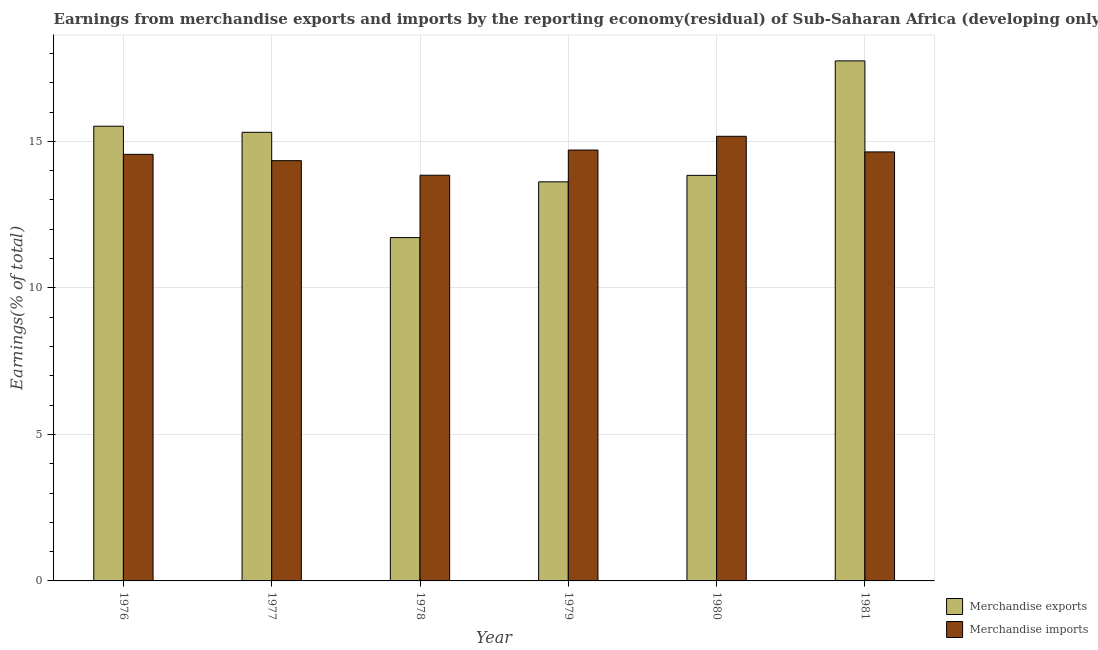How many groups of bars are there?
Provide a succinct answer. 6. In how many cases, is the number of bars for a given year not equal to the number of legend labels?
Make the answer very short. 0. What is the earnings from merchandise imports in 1977?
Ensure brevity in your answer.  14.34. Across all years, what is the maximum earnings from merchandise imports?
Your answer should be very brief. 15.17. Across all years, what is the minimum earnings from merchandise exports?
Offer a terse response. 11.72. In which year was the earnings from merchandise imports minimum?
Your answer should be compact. 1978. What is the total earnings from merchandise imports in the graph?
Your answer should be compact. 87.26. What is the difference between the earnings from merchandise exports in 1977 and that in 1979?
Your answer should be compact. 1.69. What is the difference between the earnings from merchandise exports in 1976 and the earnings from merchandise imports in 1981?
Your answer should be very brief. -2.23. What is the average earnings from merchandise imports per year?
Provide a succinct answer. 14.54. In the year 1977, what is the difference between the earnings from merchandise exports and earnings from merchandise imports?
Give a very brief answer. 0. In how many years, is the earnings from merchandise exports greater than 11 %?
Your answer should be compact. 6. What is the ratio of the earnings from merchandise imports in 1977 to that in 1980?
Give a very brief answer. 0.95. Is the earnings from merchandise imports in 1976 less than that in 1979?
Provide a succinct answer. Yes. Is the difference between the earnings from merchandise imports in 1976 and 1981 greater than the difference between the earnings from merchandise exports in 1976 and 1981?
Provide a short and direct response. No. What is the difference between the highest and the second highest earnings from merchandise imports?
Offer a very short reply. 0.47. What is the difference between the highest and the lowest earnings from merchandise exports?
Make the answer very short. 6.03. Is the sum of the earnings from merchandise imports in 1978 and 1979 greater than the maximum earnings from merchandise exports across all years?
Keep it short and to the point. Yes. What does the 2nd bar from the left in 1979 represents?
Your response must be concise. Merchandise imports. What does the 1st bar from the right in 1977 represents?
Your answer should be very brief. Merchandise imports. Are all the bars in the graph horizontal?
Provide a succinct answer. No. How many years are there in the graph?
Keep it short and to the point. 6. What is the difference between two consecutive major ticks on the Y-axis?
Provide a succinct answer. 5. Does the graph contain grids?
Make the answer very short. Yes. Where does the legend appear in the graph?
Your answer should be very brief. Bottom right. How are the legend labels stacked?
Your answer should be very brief. Vertical. What is the title of the graph?
Your answer should be very brief. Earnings from merchandise exports and imports by the reporting economy(residual) of Sub-Saharan Africa (developing only). What is the label or title of the X-axis?
Provide a succinct answer. Year. What is the label or title of the Y-axis?
Give a very brief answer. Earnings(% of total). What is the Earnings(% of total) in Merchandise exports in 1976?
Provide a short and direct response. 15.52. What is the Earnings(% of total) of Merchandise imports in 1976?
Offer a terse response. 14.56. What is the Earnings(% of total) in Merchandise exports in 1977?
Provide a succinct answer. 15.31. What is the Earnings(% of total) of Merchandise imports in 1977?
Your answer should be very brief. 14.34. What is the Earnings(% of total) in Merchandise exports in 1978?
Your answer should be compact. 11.72. What is the Earnings(% of total) in Merchandise imports in 1978?
Your response must be concise. 13.84. What is the Earnings(% of total) of Merchandise exports in 1979?
Keep it short and to the point. 13.62. What is the Earnings(% of total) of Merchandise imports in 1979?
Ensure brevity in your answer.  14.7. What is the Earnings(% of total) in Merchandise exports in 1980?
Ensure brevity in your answer.  13.84. What is the Earnings(% of total) of Merchandise imports in 1980?
Your response must be concise. 15.17. What is the Earnings(% of total) of Merchandise exports in 1981?
Your answer should be compact. 17.75. What is the Earnings(% of total) in Merchandise imports in 1981?
Your answer should be compact. 14.64. Across all years, what is the maximum Earnings(% of total) of Merchandise exports?
Your response must be concise. 17.75. Across all years, what is the maximum Earnings(% of total) of Merchandise imports?
Provide a short and direct response. 15.17. Across all years, what is the minimum Earnings(% of total) in Merchandise exports?
Your answer should be compact. 11.72. Across all years, what is the minimum Earnings(% of total) of Merchandise imports?
Offer a very short reply. 13.84. What is the total Earnings(% of total) in Merchandise exports in the graph?
Your answer should be compact. 87.74. What is the total Earnings(% of total) in Merchandise imports in the graph?
Your answer should be compact. 87.26. What is the difference between the Earnings(% of total) of Merchandise exports in 1976 and that in 1977?
Offer a very short reply. 0.21. What is the difference between the Earnings(% of total) of Merchandise imports in 1976 and that in 1977?
Your answer should be very brief. 0.22. What is the difference between the Earnings(% of total) in Merchandise exports in 1976 and that in 1978?
Offer a terse response. 3.8. What is the difference between the Earnings(% of total) in Merchandise imports in 1976 and that in 1978?
Your answer should be very brief. 0.71. What is the difference between the Earnings(% of total) in Merchandise exports in 1976 and that in 1979?
Provide a succinct answer. 1.9. What is the difference between the Earnings(% of total) of Merchandise imports in 1976 and that in 1979?
Ensure brevity in your answer.  -0.15. What is the difference between the Earnings(% of total) in Merchandise exports in 1976 and that in 1980?
Provide a short and direct response. 1.68. What is the difference between the Earnings(% of total) of Merchandise imports in 1976 and that in 1980?
Provide a succinct answer. -0.62. What is the difference between the Earnings(% of total) of Merchandise exports in 1976 and that in 1981?
Provide a succinct answer. -2.23. What is the difference between the Earnings(% of total) of Merchandise imports in 1976 and that in 1981?
Provide a succinct answer. -0.08. What is the difference between the Earnings(% of total) in Merchandise exports in 1977 and that in 1978?
Your answer should be very brief. 3.59. What is the difference between the Earnings(% of total) in Merchandise imports in 1977 and that in 1978?
Offer a terse response. 0.5. What is the difference between the Earnings(% of total) in Merchandise exports in 1977 and that in 1979?
Offer a terse response. 1.69. What is the difference between the Earnings(% of total) in Merchandise imports in 1977 and that in 1979?
Give a very brief answer. -0.36. What is the difference between the Earnings(% of total) in Merchandise exports in 1977 and that in 1980?
Your answer should be very brief. 1.47. What is the difference between the Earnings(% of total) of Merchandise imports in 1977 and that in 1980?
Give a very brief answer. -0.83. What is the difference between the Earnings(% of total) of Merchandise exports in 1977 and that in 1981?
Offer a very short reply. -2.44. What is the difference between the Earnings(% of total) of Merchandise imports in 1977 and that in 1981?
Your answer should be compact. -0.3. What is the difference between the Earnings(% of total) in Merchandise exports in 1978 and that in 1979?
Ensure brevity in your answer.  -1.9. What is the difference between the Earnings(% of total) of Merchandise imports in 1978 and that in 1979?
Offer a terse response. -0.86. What is the difference between the Earnings(% of total) of Merchandise exports in 1978 and that in 1980?
Offer a very short reply. -2.12. What is the difference between the Earnings(% of total) of Merchandise imports in 1978 and that in 1980?
Offer a very short reply. -1.33. What is the difference between the Earnings(% of total) of Merchandise exports in 1978 and that in 1981?
Provide a short and direct response. -6.03. What is the difference between the Earnings(% of total) of Merchandise imports in 1978 and that in 1981?
Make the answer very short. -0.8. What is the difference between the Earnings(% of total) of Merchandise exports in 1979 and that in 1980?
Provide a succinct answer. -0.22. What is the difference between the Earnings(% of total) in Merchandise imports in 1979 and that in 1980?
Keep it short and to the point. -0.47. What is the difference between the Earnings(% of total) in Merchandise exports in 1979 and that in 1981?
Ensure brevity in your answer.  -4.13. What is the difference between the Earnings(% of total) of Merchandise imports in 1979 and that in 1981?
Your answer should be compact. 0.06. What is the difference between the Earnings(% of total) of Merchandise exports in 1980 and that in 1981?
Your answer should be very brief. -3.91. What is the difference between the Earnings(% of total) of Merchandise imports in 1980 and that in 1981?
Provide a short and direct response. 0.53. What is the difference between the Earnings(% of total) of Merchandise exports in 1976 and the Earnings(% of total) of Merchandise imports in 1977?
Your answer should be very brief. 1.18. What is the difference between the Earnings(% of total) of Merchandise exports in 1976 and the Earnings(% of total) of Merchandise imports in 1978?
Give a very brief answer. 1.67. What is the difference between the Earnings(% of total) in Merchandise exports in 1976 and the Earnings(% of total) in Merchandise imports in 1979?
Your answer should be compact. 0.81. What is the difference between the Earnings(% of total) in Merchandise exports in 1976 and the Earnings(% of total) in Merchandise imports in 1980?
Keep it short and to the point. 0.34. What is the difference between the Earnings(% of total) in Merchandise exports in 1976 and the Earnings(% of total) in Merchandise imports in 1981?
Ensure brevity in your answer.  0.88. What is the difference between the Earnings(% of total) in Merchandise exports in 1977 and the Earnings(% of total) in Merchandise imports in 1978?
Provide a short and direct response. 1.47. What is the difference between the Earnings(% of total) in Merchandise exports in 1977 and the Earnings(% of total) in Merchandise imports in 1979?
Ensure brevity in your answer.  0.61. What is the difference between the Earnings(% of total) in Merchandise exports in 1977 and the Earnings(% of total) in Merchandise imports in 1980?
Ensure brevity in your answer.  0.14. What is the difference between the Earnings(% of total) of Merchandise exports in 1977 and the Earnings(% of total) of Merchandise imports in 1981?
Offer a terse response. 0.67. What is the difference between the Earnings(% of total) in Merchandise exports in 1978 and the Earnings(% of total) in Merchandise imports in 1979?
Keep it short and to the point. -2.99. What is the difference between the Earnings(% of total) in Merchandise exports in 1978 and the Earnings(% of total) in Merchandise imports in 1980?
Provide a succinct answer. -3.46. What is the difference between the Earnings(% of total) of Merchandise exports in 1978 and the Earnings(% of total) of Merchandise imports in 1981?
Your response must be concise. -2.92. What is the difference between the Earnings(% of total) in Merchandise exports in 1979 and the Earnings(% of total) in Merchandise imports in 1980?
Offer a very short reply. -1.55. What is the difference between the Earnings(% of total) in Merchandise exports in 1979 and the Earnings(% of total) in Merchandise imports in 1981?
Ensure brevity in your answer.  -1.02. What is the difference between the Earnings(% of total) of Merchandise exports in 1980 and the Earnings(% of total) of Merchandise imports in 1981?
Ensure brevity in your answer.  -0.8. What is the average Earnings(% of total) in Merchandise exports per year?
Keep it short and to the point. 14.62. What is the average Earnings(% of total) in Merchandise imports per year?
Offer a very short reply. 14.54. In the year 1976, what is the difference between the Earnings(% of total) in Merchandise exports and Earnings(% of total) in Merchandise imports?
Give a very brief answer. 0.96. In the year 1977, what is the difference between the Earnings(% of total) of Merchandise exports and Earnings(% of total) of Merchandise imports?
Make the answer very short. 0.97. In the year 1978, what is the difference between the Earnings(% of total) of Merchandise exports and Earnings(% of total) of Merchandise imports?
Provide a short and direct response. -2.13. In the year 1979, what is the difference between the Earnings(% of total) in Merchandise exports and Earnings(% of total) in Merchandise imports?
Your response must be concise. -1.08. In the year 1980, what is the difference between the Earnings(% of total) of Merchandise exports and Earnings(% of total) of Merchandise imports?
Your answer should be compact. -1.33. In the year 1981, what is the difference between the Earnings(% of total) in Merchandise exports and Earnings(% of total) in Merchandise imports?
Offer a terse response. 3.11. What is the ratio of the Earnings(% of total) in Merchandise exports in 1976 to that in 1977?
Provide a short and direct response. 1.01. What is the ratio of the Earnings(% of total) in Merchandise imports in 1976 to that in 1977?
Offer a very short reply. 1.02. What is the ratio of the Earnings(% of total) in Merchandise exports in 1976 to that in 1978?
Provide a short and direct response. 1.32. What is the ratio of the Earnings(% of total) in Merchandise imports in 1976 to that in 1978?
Offer a terse response. 1.05. What is the ratio of the Earnings(% of total) of Merchandise exports in 1976 to that in 1979?
Offer a very short reply. 1.14. What is the ratio of the Earnings(% of total) of Merchandise exports in 1976 to that in 1980?
Provide a succinct answer. 1.12. What is the ratio of the Earnings(% of total) of Merchandise imports in 1976 to that in 1980?
Offer a very short reply. 0.96. What is the ratio of the Earnings(% of total) in Merchandise exports in 1976 to that in 1981?
Your answer should be compact. 0.87. What is the ratio of the Earnings(% of total) of Merchandise imports in 1976 to that in 1981?
Provide a short and direct response. 0.99. What is the ratio of the Earnings(% of total) in Merchandise exports in 1977 to that in 1978?
Make the answer very short. 1.31. What is the ratio of the Earnings(% of total) in Merchandise imports in 1977 to that in 1978?
Make the answer very short. 1.04. What is the ratio of the Earnings(% of total) of Merchandise exports in 1977 to that in 1979?
Offer a very short reply. 1.12. What is the ratio of the Earnings(% of total) of Merchandise imports in 1977 to that in 1979?
Your response must be concise. 0.98. What is the ratio of the Earnings(% of total) in Merchandise exports in 1977 to that in 1980?
Your answer should be compact. 1.11. What is the ratio of the Earnings(% of total) in Merchandise imports in 1977 to that in 1980?
Your answer should be compact. 0.95. What is the ratio of the Earnings(% of total) of Merchandise exports in 1977 to that in 1981?
Provide a short and direct response. 0.86. What is the ratio of the Earnings(% of total) in Merchandise imports in 1977 to that in 1981?
Provide a succinct answer. 0.98. What is the ratio of the Earnings(% of total) of Merchandise exports in 1978 to that in 1979?
Make the answer very short. 0.86. What is the ratio of the Earnings(% of total) of Merchandise imports in 1978 to that in 1979?
Make the answer very short. 0.94. What is the ratio of the Earnings(% of total) of Merchandise exports in 1978 to that in 1980?
Your answer should be very brief. 0.85. What is the ratio of the Earnings(% of total) of Merchandise imports in 1978 to that in 1980?
Keep it short and to the point. 0.91. What is the ratio of the Earnings(% of total) of Merchandise exports in 1978 to that in 1981?
Your response must be concise. 0.66. What is the ratio of the Earnings(% of total) in Merchandise imports in 1978 to that in 1981?
Provide a short and direct response. 0.95. What is the ratio of the Earnings(% of total) of Merchandise exports in 1979 to that in 1980?
Provide a short and direct response. 0.98. What is the ratio of the Earnings(% of total) of Merchandise imports in 1979 to that in 1980?
Provide a short and direct response. 0.97. What is the ratio of the Earnings(% of total) of Merchandise exports in 1979 to that in 1981?
Offer a terse response. 0.77. What is the ratio of the Earnings(% of total) of Merchandise exports in 1980 to that in 1981?
Ensure brevity in your answer.  0.78. What is the ratio of the Earnings(% of total) of Merchandise imports in 1980 to that in 1981?
Your answer should be very brief. 1.04. What is the difference between the highest and the second highest Earnings(% of total) in Merchandise exports?
Keep it short and to the point. 2.23. What is the difference between the highest and the second highest Earnings(% of total) of Merchandise imports?
Your response must be concise. 0.47. What is the difference between the highest and the lowest Earnings(% of total) of Merchandise exports?
Provide a short and direct response. 6.03. What is the difference between the highest and the lowest Earnings(% of total) of Merchandise imports?
Make the answer very short. 1.33. 